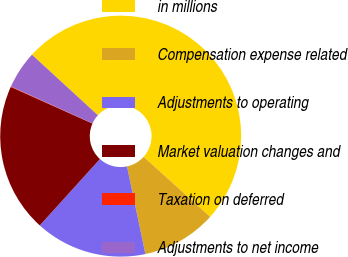<chart> <loc_0><loc_0><loc_500><loc_500><pie_chart><fcel>in millions<fcel>Compensation expense related<fcel>Adjustments to operating<fcel>Market valuation changes and<fcel>Taxation on deferred<fcel>Adjustments to net income<nl><fcel>49.87%<fcel>10.03%<fcel>15.01%<fcel>19.99%<fcel>0.07%<fcel>5.05%<nl></chart> 